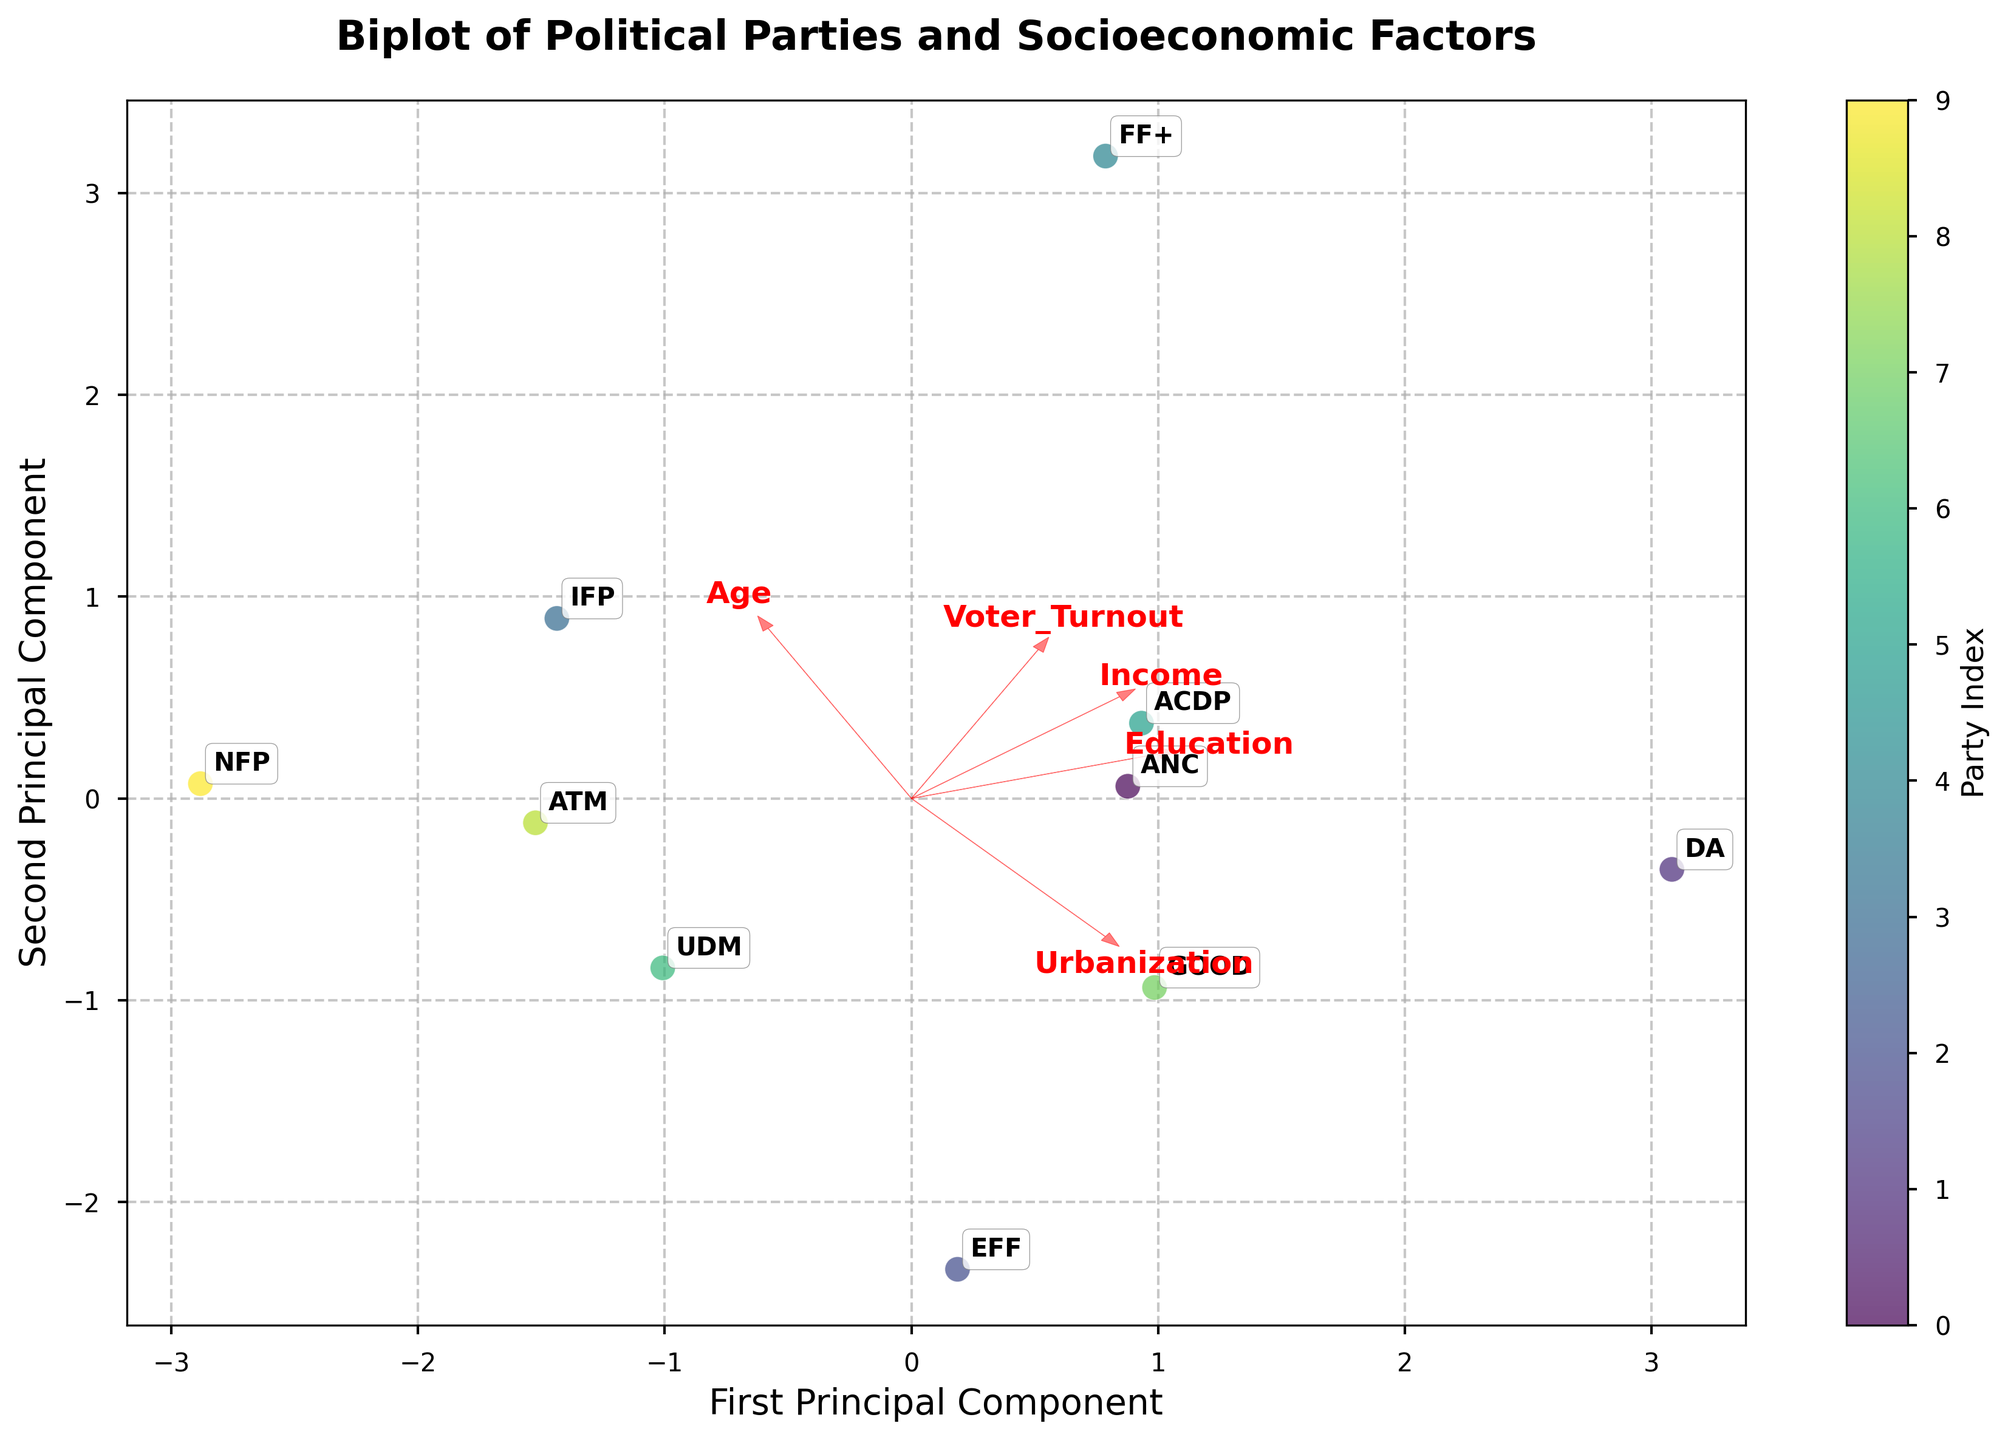What does the title of the figure indicate? The title of the figure is "Biplot of Political Parties and Socioeconomic Factors." This indicates that the figure visualizes the relationships between various political parties and socioeconomic factors based on principal component analysis (PCA).
Answer: Biplot of Political Parties and Socioeconomic Factors What do the arrows in the biplot represent? The arrows in the biplot represent the eigenvectors of the socioeconomic factors, showing the direction and magnitude of each factor's contribution to the principal components.
Answer: Eigenvectors of socioeconomic factors Which political party is most associated with higher income and education levels in the biplot? By observing the position of the party in relation to the arrows representing Income and Education, the DA (Democratic Alliance) appears to be the closest to these arrows, indicating an association with higher income and education levels.
Answer: DA Which two socioeconomic factors seem to have the closest relationship based on the direction of the arrows? The directions of the arrows for Income and Education are very similar, indicating that these two factors are closely related.
Answer: Income and Education Which political party is positioned close to the origin of the principal component axes? The political party positioned close to the origin of the principal component axes is the ANC (African National Congress).
Answer: ANC What can be inferred about the FF+ party regarding the age and voter turnout factors? The FF+ party appears to be positioned in the direction of the arrows representing Age and Voter Turnout, suggesting it is associated with higher age and higher voter turnout.
Answer: Higher age and higher voter turnout How does the urbanization level of the EFF party compare to that of the GOOD party? The EFF party is situated closer to the Urbanization arrow compared to the GOOD party, indicating a higher level of urbanization.
Answer: Higher level of urbanization Which party is least associated with education based on the biplot? The NFP (National Freedom Party) appears to be positioned furthest away from the Education arrow, indicating it is least associated with education.
Answer: NFP 